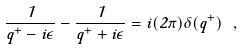<formula> <loc_0><loc_0><loc_500><loc_500>\frac { 1 } { q ^ { + } - i \epsilon } - \frac { 1 } { q ^ { + } + i \epsilon } = i ( 2 \pi ) \delta ( q ^ { + } ) \ ,</formula> 